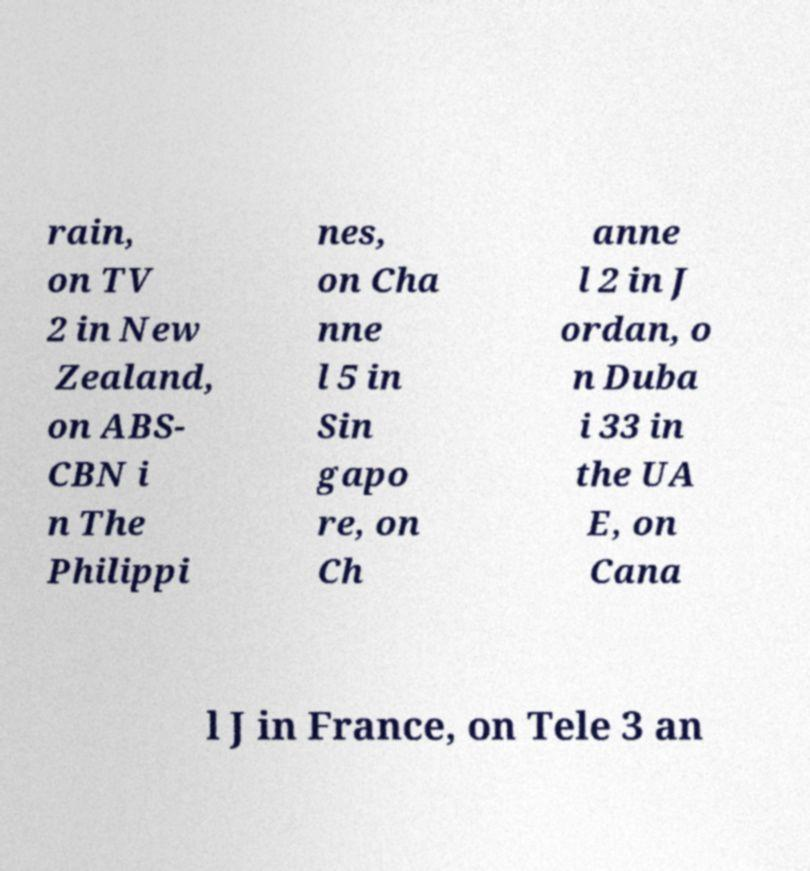For documentation purposes, I need the text within this image transcribed. Could you provide that? rain, on TV 2 in New Zealand, on ABS- CBN i n The Philippi nes, on Cha nne l 5 in Sin gapo re, on Ch anne l 2 in J ordan, o n Duba i 33 in the UA E, on Cana l J in France, on Tele 3 an 